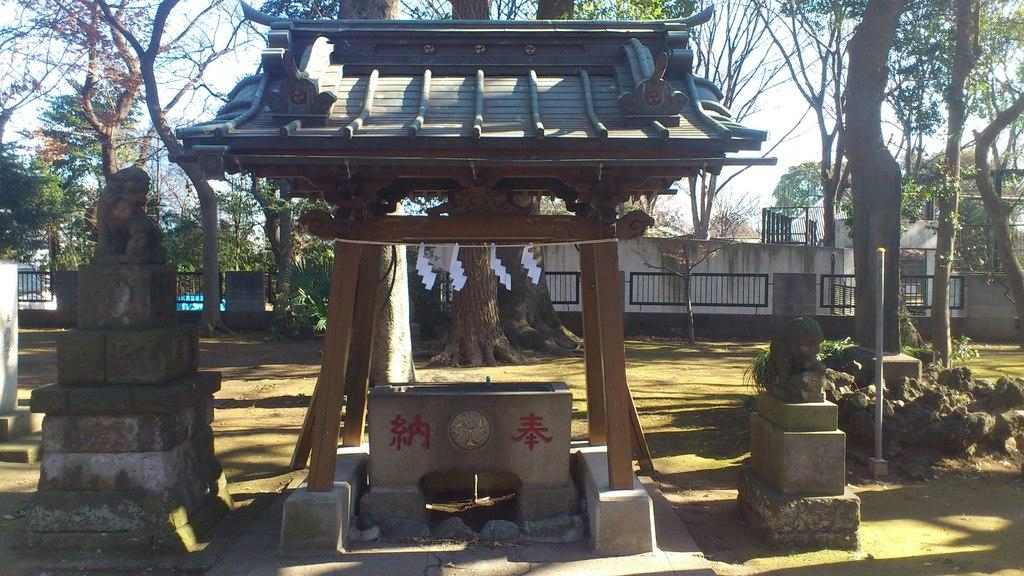What can be seen in the image that represents artistic creations? There are statues in the image. What is written or displayed on a wall in the image? There is text on a wall in the image. What type of structure is present with poles in the image? There is a shed with poles in the image. What type of barrier can be seen in the background of the image? There is a fence in the background of the image. What type of vegetation is visible in the background of the image? There is a group of trees and plants in the background of the image. What part of the natural environment is visible in the background of the image? The sky is visible in the background of the image. What type of jelly can be seen dripping from the statues in the image? There is no jelly present in the image; it features statues, text on a wall, a shed with poles, a fence, trees, plants, and the sky. What type of beast is lurking behind the shed in the image? There is no beast present in the image; it only features statues, text on a wall, a shed with poles, a fence, trees, plants, and the sky. 